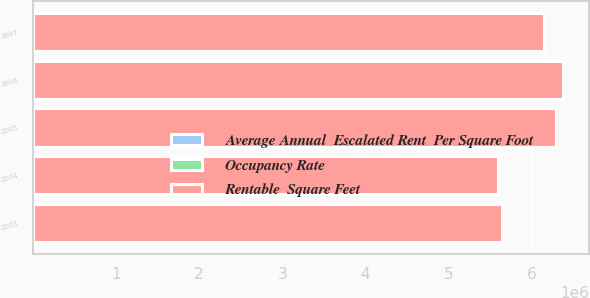<chart> <loc_0><loc_0><loc_500><loc_500><stacked_bar_chart><ecel><fcel>2007<fcel>2006<fcel>2005<fcel>2004<fcel>2003<nl><fcel>Rentable  Square Feet<fcel>6.139e+06<fcel>6.37e+06<fcel>6.29e+06<fcel>5.589e+06<fcel>5.64e+06<nl><fcel>Occupancy Rate<fcel>93.7<fcel>93.6<fcel>94.7<fcel>97.6<fcel>95.1<nl><fcel>Average Annual  Escalated Rent  Per Square Foot<fcel>26.16<fcel>25.17<fcel>24.04<fcel>23.08<fcel>22.35<nl></chart> 